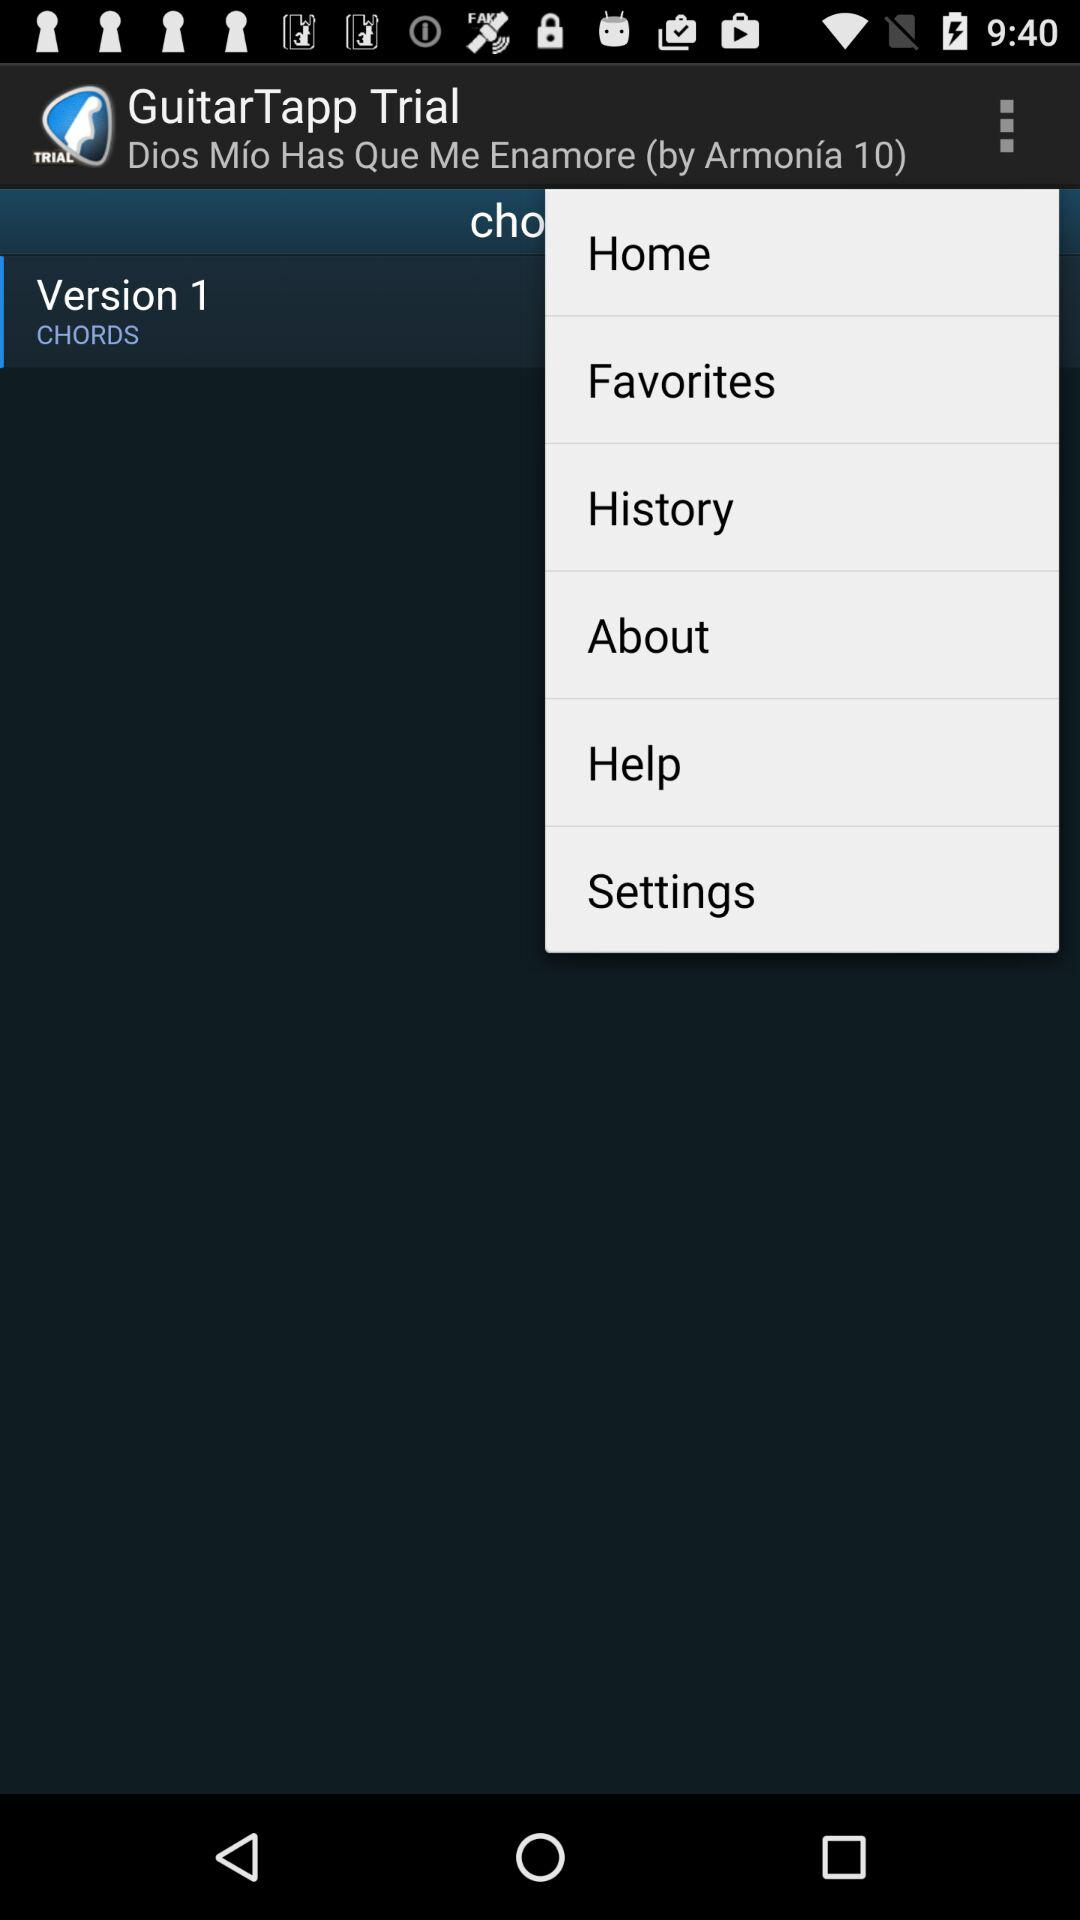What is the name of the application? The name of the application is "GuitarTapp Trial". 